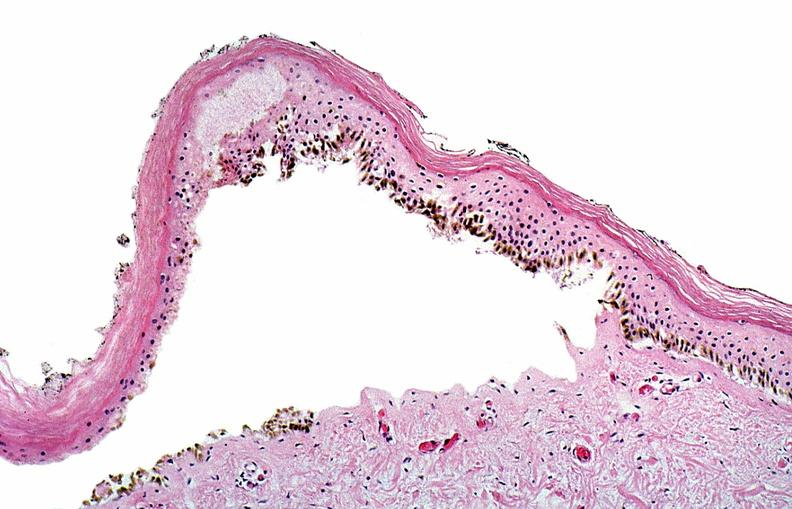what does this image show?
Answer the question using a single word or phrase. Thermal burned skin 